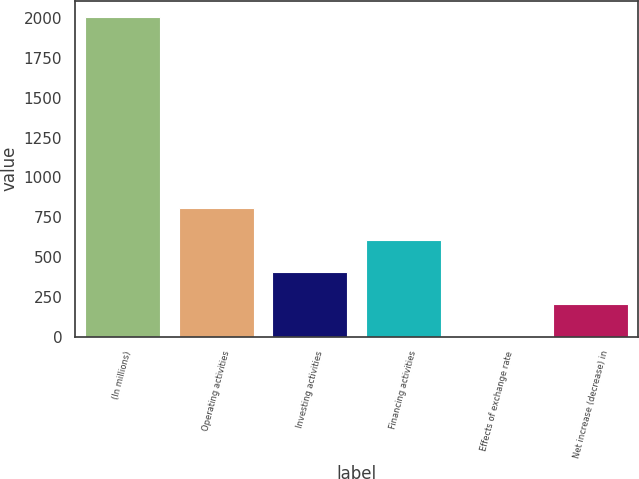Convert chart to OTSL. <chart><loc_0><loc_0><loc_500><loc_500><bar_chart><fcel>(In millions)<fcel>Operating activities<fcel>Investing activities<fcel>Financing activities<fcel>Effects of exchange rate<fcel>Net increase (decrease) in<nl><fcel>2010<fcel>805.8<fcel>404.4<fcel>605.1<fcel>3<fcel>203.7<nl></chart> 